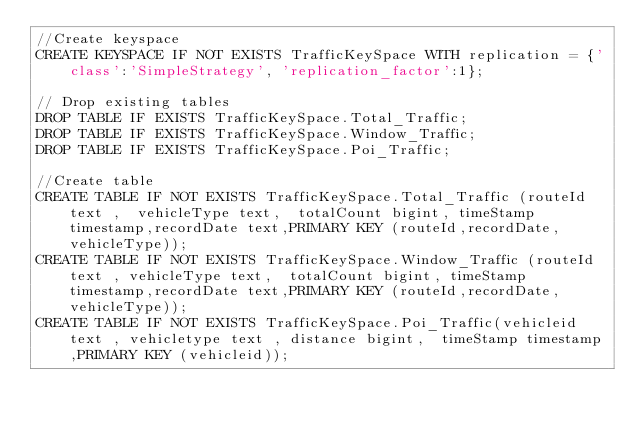Convert code to text. <code><loc_0><loc_0><loc_500><loc_500><_SQL_>//Create keyspace
CREATE KEYSPACE IF NOT EXISTS TrafficKeySpace WITH replication = {'class':'SimpleStrategy', 'replication_factor':1};

// Drop existing tables
DROP TABLE IF EXISTS TrafficKeySpace.Total_Traffic;
DROP TABLE IF EXISTS TrafficKeySpace.Window_Traffic;
DROP TABLE IF EXISTS TrafficKeySpace.Poi_Traffic;

//Create table
CREATE TABLE IF NOT EXISTS TrafficKeySpace.Total_Traffic (routeId text ,  vehicleType text,  totalCount bigint, timeStamp timestamp,recordDate text,PRIMARY KEY (routeId,recordDate,vehicleType));
CREATE TABLE IF NOT EXISTS TrafficKeySpace.Window_Traffic (routeId text , vehicleType text,  totalCount bigint, timeStamp timestamp,recordDate text,PRIMARY KEY (routeId,recordDate,vehicleType));
CREATE TABLE IF NOT EXISTS TrafficKeySpace.Poi_Traffic(vehicleid text , vehicletype text , distance bigint,  timeStamp timestamp,PRIMARY KEY (vehicleid));

</code> 